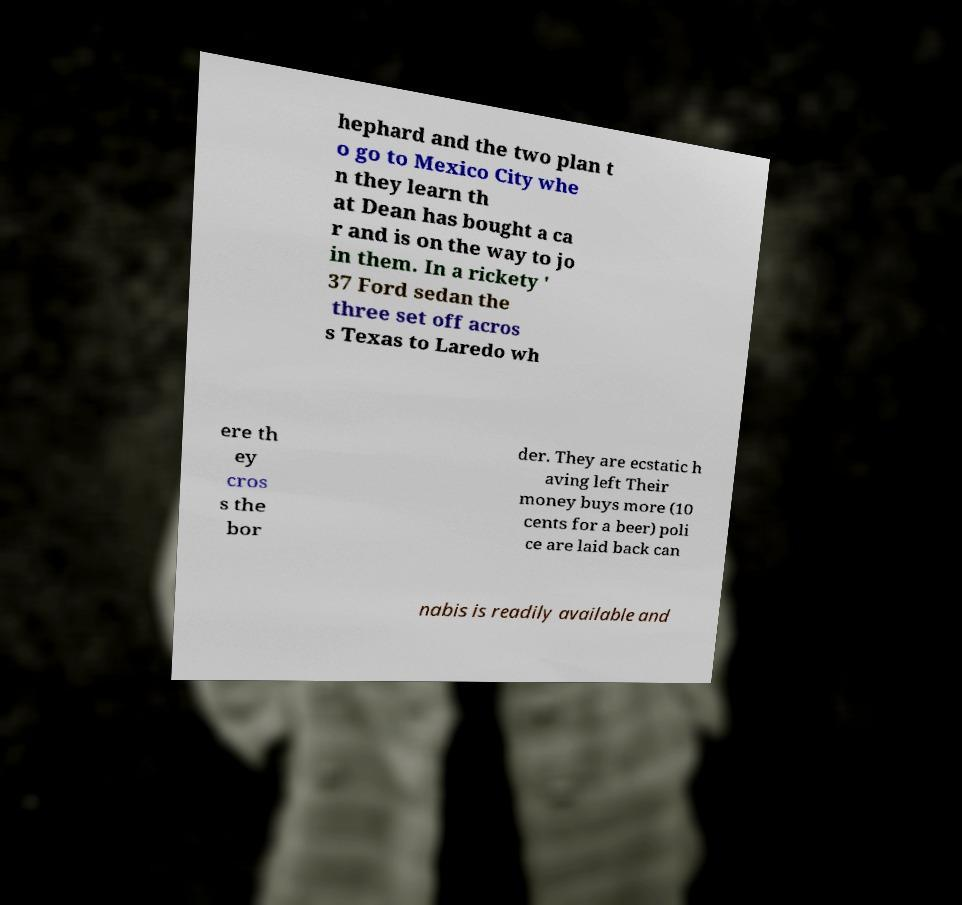Could you extract and type out the text from this image? hephard and the two plan t o go to Mexico City whe n they learn th at Dean has bought a ca r and is on the way to jo in them. In a rickety ' 37 Ford sedan the three set off acros s Texas to Laredo wh ere th ey cros s the bor der. They are ecstatic h aving left Their money buys more (10 cents for a beer) poli ce are laid back can nabis is readily available and 